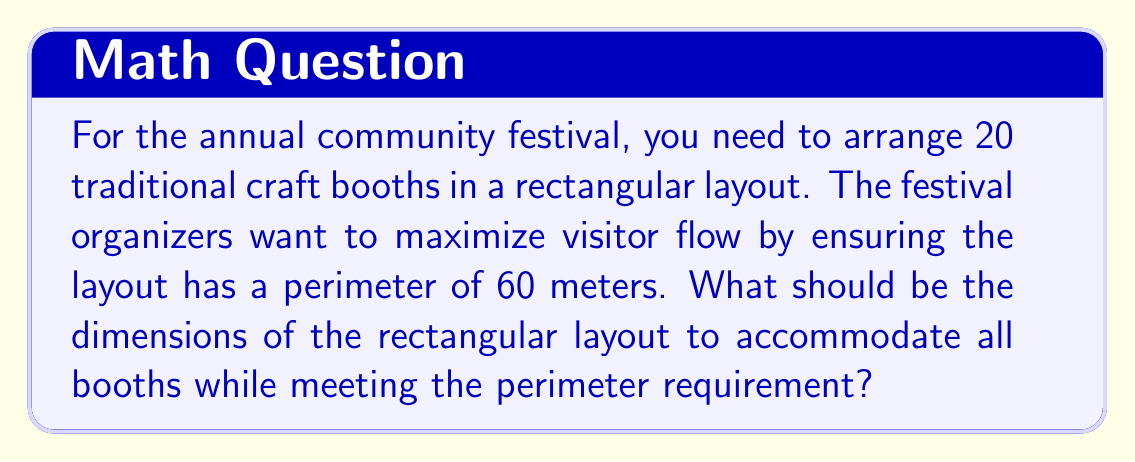Could you help me with this problem? Let's approach this step-by-step:

1) Let the length of the rectangle be $l$ meters and the width be $w$ meters.

2) Given that the perimeter is 60 meters, we can write:
   $$2l + 2w = 60$$

3) Simplifying:
   $$l + w = 30$$

4) The area of the rectangle will be $A = l * w$. We need to maximize this area.

5) We can express $w$ in terms of $l$:
   $$w = 30 - l$$

6) Now, the area function becomes:
   $$A(l) = l(30-l) = 30l - l^2$$

7) To find the maximum area, we differentiate $A(l)$ with respect to $l$ and set it to zero:
   $$\frac{dA}{dl} = 30 - 2l = 0$$

8) Solving this equation:
   $$30 - 2l = 0$$
   $$2l = 30$$
   $$l = 15$$

9) Since $l + w = 30$, when $l = 15$, $w$ must also be 15.

10) To verify this is a maximum, we can check the second derivative:
    $$\frac{d^2A}{dl^2} = -2$$
    This is negative, confirming we have a maximum.

11) The dimensions are 15m x 15m, giving an area of 225 sq meters.

12) Assuming each booth needs a minimum of 9 sq meters (3m x 3m), this layout can accommodate up to 25 booths, which is more than enough for the 20 required.
Answer: 15m x 15m 